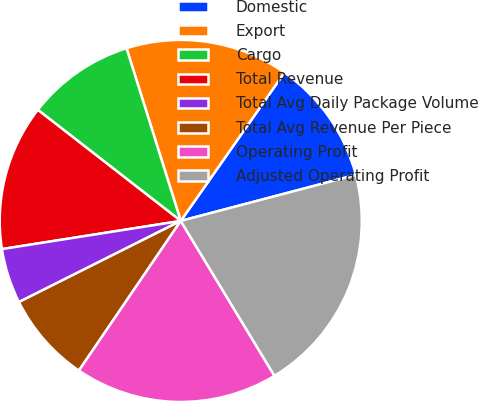Convert chart. <chart><loc_0><loc_0><loc_500><loc_500><pie_chart><fcel>Domestic<fcel>Export<fcel>Cargo<fcel>Total Revenue<fcel>Total Avg Daily Package Volume<fcel>Total Avg Revenue Per Piece<fcel>Operating Profit<fcel>Adjusted Operating Profit<nl><fcel>11.2%<fcel>14.55%<fcel>9.64%<fcel>13.0%<fcel>4.91%<fcel>8.09%<fcel>18.17%<fcel>20.43%<nl></chart> 